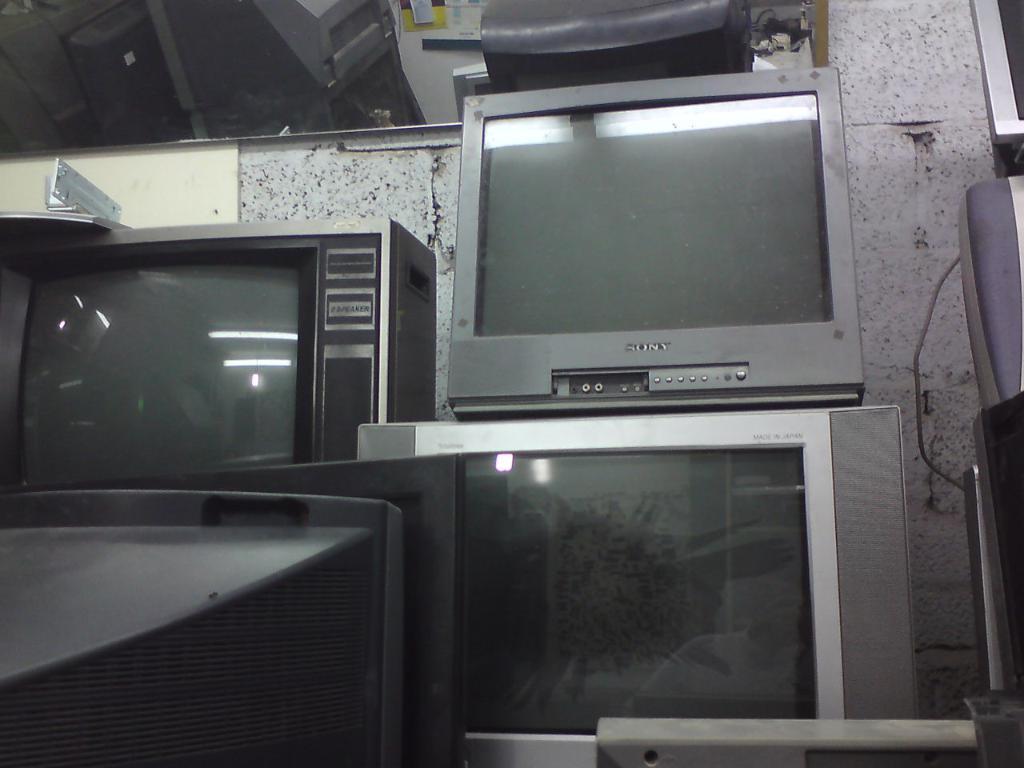What tv brand is it?
Your answer should be very brief. Sony. Is any text shown on the left tv?
Your answer should be compact. No. 